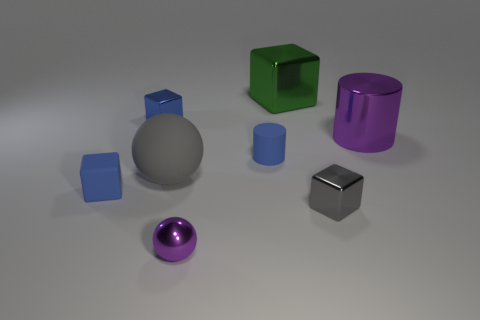What is the material of the purple sphere?
Your response must be concise. Metal. Is there anything else that has the same color as the small cylinder?
Ensure brevity in your answer.  Yes. Does the big purple object have the same material as the gray cube?
Provide a succinct answer. Yes. There is a sphere that is in front of the tiny rubber thing that is on the left side of the big gray rubber sphere; what number of blue rubber things are left of it?
Offer a very short reply. 1. How many blue objects are there?
Your answer should be very brief. 3. Is the number of green objects on the right side of the purple metallic cylinder less than the number of big spheres in front of the large gray ball?
Make the answer very short. No. Are there fewer big shiny cylinders that are in front of the small cylinder than big balls?
Your answer should be very brief. Yes. What material is the green object behind the large thing that is right of the block that is to the right of the big cube?
Your answer should be compact. Metal. How many things are either tiny blocks to the right of the big green metallic thing or matte objects that are to the right of the rubber ball?
Your response must be concise. 2. What material is the green object that is the same shape as the blue metal object?
Your answer should be very brief. Metal. 